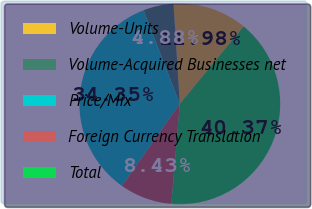Convert chart to OTSL. <chart><loc_0><loc_0><loc_500><loc_500><pie_chart><fcel>Volume-Units<fcel>Volume-Acquired Businesses net<fcel>Price/Mix<fcel>Foreign Currency Translation<fcel>Total<nl><fcel>11.98%<fcel>4.88%<fcel>34.35%<fcel>8.43%<fcel>40.37%<nl></chart> 